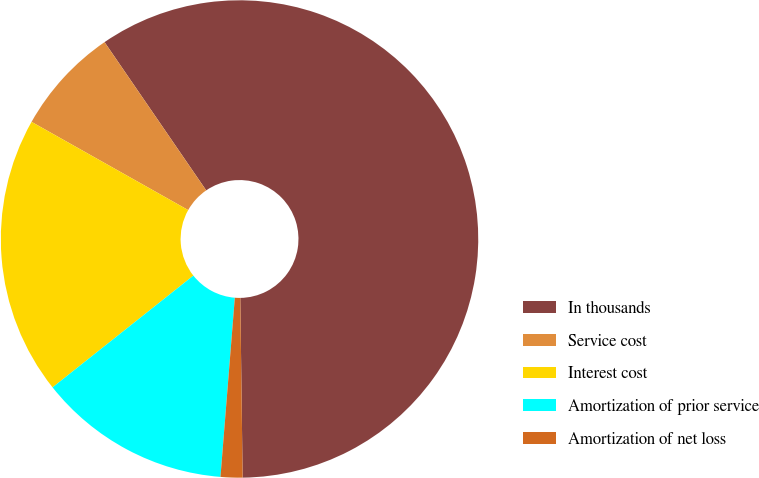Convert chart to OTSL. <chart><loc_0><loc_0><loc_500><loc_500><pie_chart><fcel>In thousands<fcel>Service cost<fcel>Interest cost<fcel>Amortization of prior service<fcel>Amortization of net loss<nl><fcel>59.36%<fcel>7.27%<fcel>18.84%<fcel>13.05%<fcel>1.48%<nl></chart> 